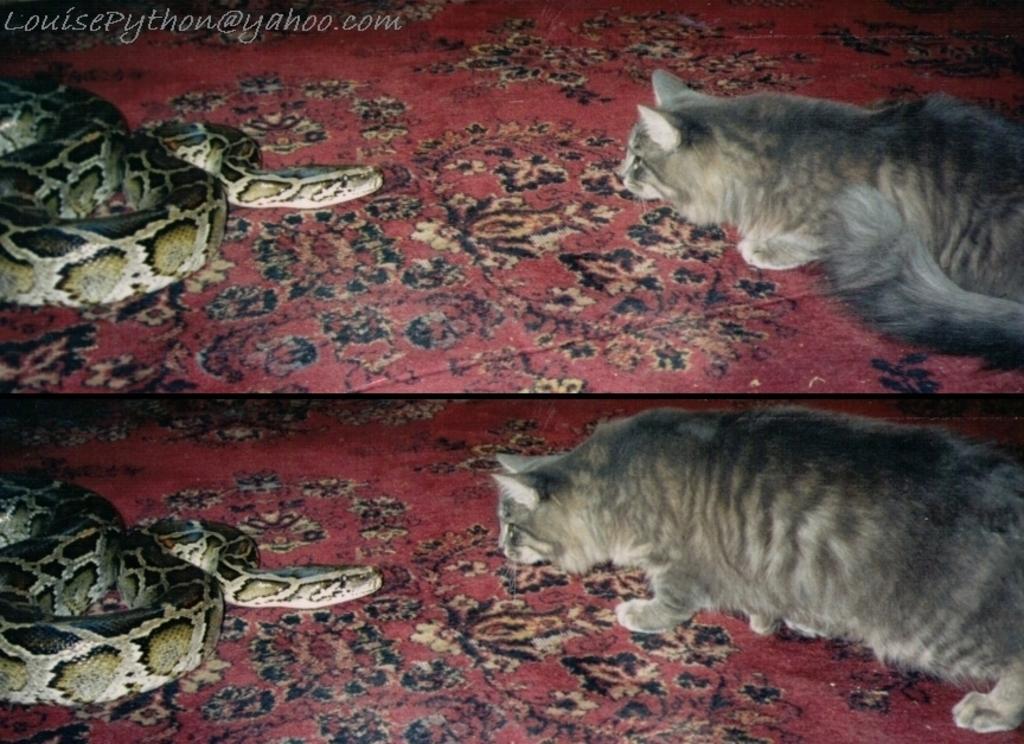In one or two sentences, can you explain what this image depicts? This picture is a collage picture. On the left side of the image there are snakes. On the right side of the image their cats. At the bottom there are red meats. 